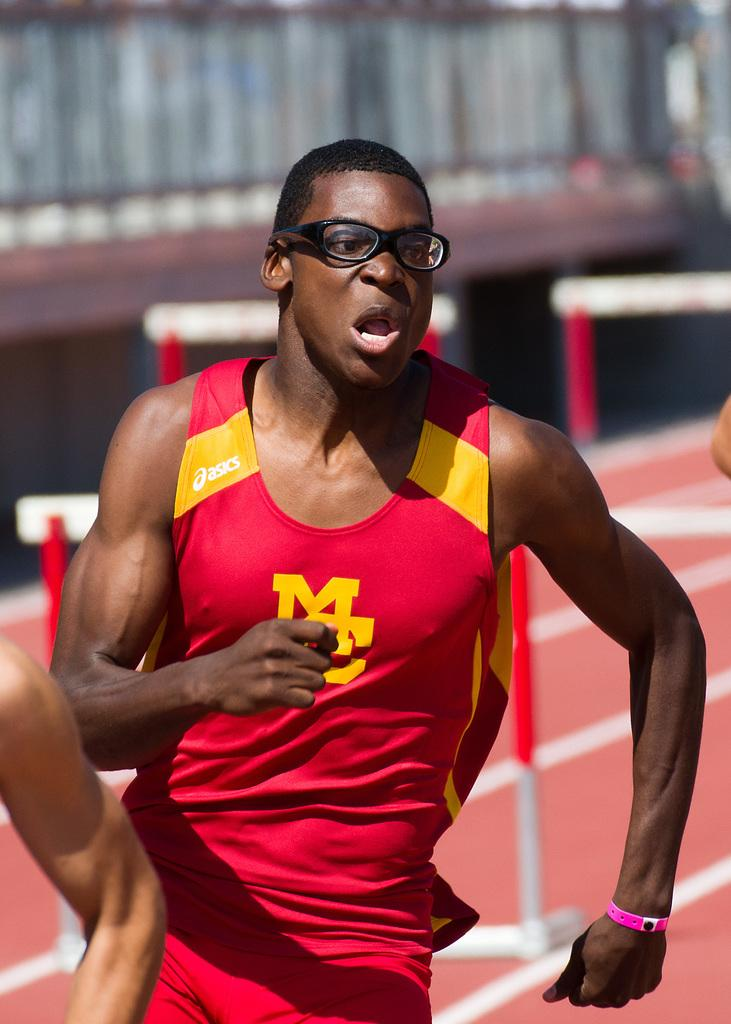<image>
Present a compact description of the photo's key features. runner wearing glasses with the letters M and C on his shirt. 